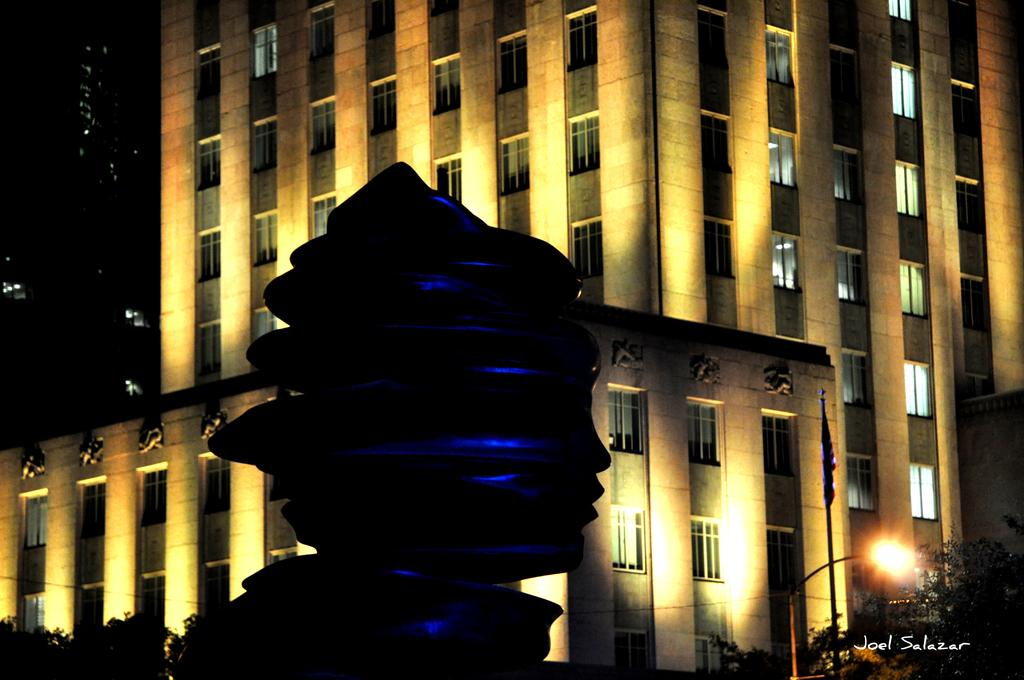What type of structures can be seen in the image? There are buildings in the image. What other objects can be seen in the image besides the buildings? There is a statue, a flag, a light pole, and trees in the image. Can you describe the flag in the image? The flag is visible in the image. What is the condition of the light pole in the image? The light pole is present in the image. What type of vegetation is in the image? There are trees in the image. Is there any text or marking at the bottom of the image? The image has a watermark at the bottom. What feature do the buildings in the image have? The buildings in the image have windows. How would you describe the overall lighting in the image? The background of the image is dark. How many fingers can be seen touching the wire in the image? There is no wire or fingers present in the image. What type of test is being conducted in the image? There is no test being conducted in the image. 